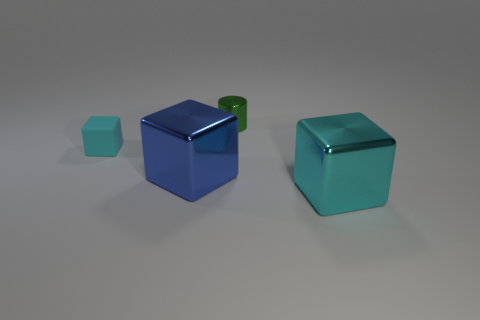Subtract all brown cylinders. Subtract all blue spheres. How many cylinders are left? 1 Add 1 small cyan cubes. How many objects exist? 5 Subtract all cylinders. How many objects are left? 3 Add 3 large metal objects. How many large metal objects exist? 5 Subtract 0 green cubes. How many objects are left? 4 Subtract all small red cubes. Subtract all large cyan metallic things. How many objects are left? 3 Add 4 cubes. How many cubes are left? 7 